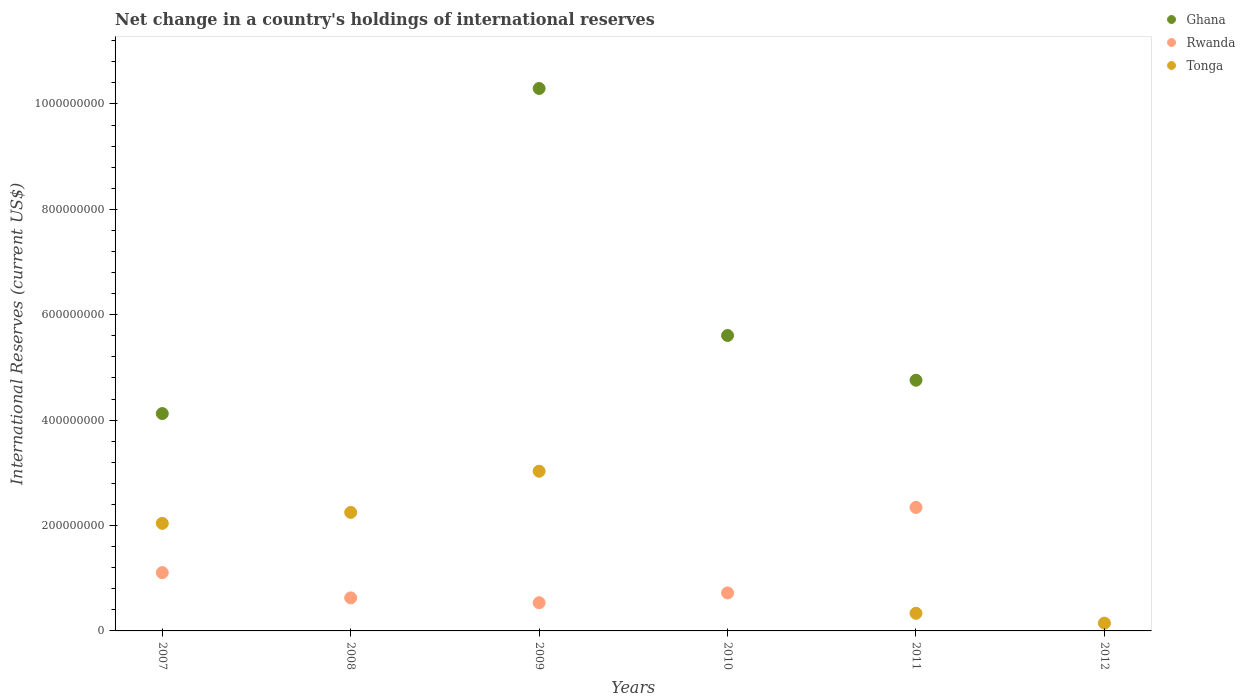How many different coloured dotlines are there?
Make the answer very short. 3. Is the number of dotlines equal to the number of legend labels?
Provide a succinct answer. No. What is the international reserves in Ghana in 2008?
Ensure brevity in your answer.  0. Across all years, what is the maximum international reserves in Ghana?
Give a very brief answer. 1.03e+09. Across all years, what is the minimum international reserves in Rwanda?
Provide a short and direct response. 0. What is the total international reserves in Rwanda in the graph?
Provide a succinct answer. 5.33e+08. What is the difference between the international reserves in Rwanda in 2007 and that in 2011?
Ensure brevity in your answer.  -1.24e+08. What is the difference between the international reserves in Ghana in 2011 and the international reserves in Tonga in 2008?
Provide a succinct answer. 2.51e+08. What is the average international reserves in Ghana per year?
Your answer should be compact. 4.13e+08. In the year 2009, what is the difference between the international reserves in Rwanda and international reserves in Tonga?
Your answer should be compact. -2.49e+08. What is the ratio of the international reserves in Tonga in 2007 to that in 2008?
Your answer should be very brief. 0.91. Is the international reserves in Ghana in 2007 less than that in 2011?
Make the answer very short. Yes. Is the difference between the international reserves in Rwanda in 2007 and 2009 greater than the difference between the international reserves in Tonga in 2007 and 2009?
Your response must be concise. Yes. What is the difference between the highest and the second highest international reserves in Tonga?
Provide a succinct answer. 7.81e+07. What is the difference between the highest and the lowest international reserves in Tonga?
Your response must be concise. 3.03e+08. In how many years, is the international reserves in Rwanda greater than the average international reserves in Rwanda taken over all years?
Give a very brief answer. 2. Is it the case that in every year, the sum of the international reserves in Tonga and international reserves in Rwanda  is greater than the international reserves in Ghana?
Your answer should be compact. No. Does the international reserves in Tonga monotonically increase over the years?
Provide a short and direct response. No. Is the international reserves in Ghana strictly greater than the international reserves in Tonga over the years?
Your answer should be compact. No. Is the international reserves in Ghana strictly less than the international reserves in Rwanda over the years?
Offer a very short reply. No. How many years are there in the graph?
Give a very brief answer. 6. Are the values on the major ticks of Y-axis written in scientific E-notation?
Make the answer very short. No. Does the graph contain any zero values?
Make the answer very short. Yes. How many legend labels are there?
Make the answer very short. 3. What is the title of the graph?
Your response must be concise. Net change in a country's holdings of international reserves. What is the label or title of the Y-axis?
Your answer should be very brief. International Reserves (current US$). What is the International Reserves (current US$) of Ghana in 2007?
Your answer should be very brief. 4.12e+08. What is the International Reserves (current US$) in Rwanda in 2007?
Give a very brief answer. 1.11e+08. What is the International Reserves (current US$) of Tonga in 2007?
Give a very brief answer. 2.04e+08. What is the International Reserves (current US$) in Ghana in 2008?
Provide a short and direct response. 0. What is the International Reserves (current US$) of Rwanda in 2008?
Offer a very short reply. 6.27e+07. What is the International Reserves (current US$) of Tonga in 2008?
Provide a succinct answer. 2.25e+08. What is the International Reserves (current US$) of Ghana in 2009?
Your answer should be very brief. 1.03e+09. What is the International Reserves (current US$) of Rwanda in 2009?
Keep it short and to the point. 5.35e+07. What is the International Reserves (current US$) in Tonga in 2009?
Give a very brief answer. 3.03e+08. What is the International Reserves (current US$) in Ghana in 2010?
Your response must be concise. 5.61e+08. What is the International Reserves (current US$) of Rwanda in 2010?
Your answer should be very brief. 7.21e+07. What is the International Reserves (current US$) of Ghana in 2011?
Keep it short and to the point. 4.76e+08. What is the International Reserves (current US$) of Rwanda in 2011?
Provide a short and direct response. 2.34e+08. What is the International Reserves (current US$) of Tonga in 2011?
Ensure brevity in your answer.  3.35e+07. What is the International Reserves (current US$) of Ghana in 2012?
Offer a terse response. 0. What is the International Reserves (current US$) of Rwanda in 2012?
Ensure brevity in your answer.  0. What is the International Reserves (current US$) in Tonga in 2012?
Make the answer very short. 1.48e+07. Across all years, what is the maximum International Reserves (current US$) in Ghana?
Provide a short and direct response. 1.03e+09. Across all years, what is the maximum International Reserves (current US$) of Rwanda?
Offer a very short reply. 2.34e+08. Across all years, what is the maximum International Reserves (current US$) of Tonga?
Your answer should be very brief. 3.03e+08. What is the total International Reserves (current US$) of Ghana in the graph?
Ensure brevity in your answer.  2.48e+09. What is the total International Reserves (current US$) of Rwanda in the graph?
Ensure brevity in your answer.  5.33e+08. What is the total International Reserves (current US$) in Tonga in the graph?
Provide a short and direct response. 7.80e+08. What is the difference between the International Reserves (current US$) of Rwanda in 2007 and that in 2008?
Offer a terse response. 4.79e+07. What is the difference between the International Reserves (current US$) of Tonga in 2007 and that in 2008?
Make the answer very short. -2.07e+07. What is the difference between the International Reserves (current US$) in Ghana in 2007 and that in 2009?
Your answer should be compact. -6.17e+08. What is the difference between the International Reserves (current US$) of Rwanda in 2007 and that in 2009?
Provide a succinct answer. 5.71e+07. What is the difference between the International Reserves (current US$) in Tonga in 2007 and that in 2009?
Provide a succinct answer. -9.89e+07. What is the difference between the International Reserves (current US$) of Ghana in 2007 and that in 2010?
Keep it short and to the point. -1.48e+08. What is the difference between the International Reserves (current US$) of Rwanda in 2007 and that in 2010?
Provide a succinct answer. 3.85e+07. What is the difference between the International Reserves (current US$) in Ghana in 2007 and that in 2011?
Make the answer very short. -6.33e+07. What is the difference between the International Reserves (current US$) in Rwanda in 2007 and that in 2011?
Ensure brevity in your answer.  -1.24e+08. What is the difference between the International Reserves (current US$) of Tonga in 2007 and that in 2011?
Your answer should be compact. 1.71e+08. What is the difference between the International Reserves (current US$) in Tonga in 2007 and that in 2012?
Ensure brevity in your answer.  1.89e+08. What is the difference between the International Reserves (current US$) in Rwanda in 2008 and that in 2009?
Give a very brief answer. 9.17e+06. What is the difference between the International Reserves (current US$) in Tonga in 2008 and that in 2009?
Your answer should be compact. -7.81e+07. What is the difference between the International Reserves (current US$) in Rwanda in 2008 and that in 2010?
Offer a very short reply. -9.38e+06. What is the difference between the International Reserves (current US$) of Rwanda in 2008 and that in 2011?
Provide a succinct answer. -1.72e+08. What is the difference between the International Reserves (current US$) in Tonga in 2008 and that in 2011?
Provide a succinct answer. 1.91e+08. What is the difference between the International Reserves (current US$) of Tonga in 2008 and that in 2012?
Make the answer very short. 2.10e+08. What is the difference between the International Reserves (current US$) in Ghana in 2009 and that in 2010?
Keep it short and to the point. 4.69e+08. What is the difference between the International Reserves (current US$) of Rwanda in 2009 and that in 2010?
Your answer should be very brief. -1.85e+07. What is the difference between the International Reserves (current US$) in Ghana in 2009 and that in 2011?
Your answer should be compact. 5.54e+08. What is the difference between the International Reserves (current US$) of Rwanda in 2009 and that in 2011?
Provide a short and direct response. -1.81e+08. What is the difference between the International Reserves (current US$) in Tonga in 2009 and that in 2011?
Offer a terse response. 2.70e+08. What is the difference between the International Reserves (current US$) in Tonga in 2009 and that in 2012?
Give a very brief answer. 2.88e+08. What is the difference between the International Reserves (current US$) in Ghana in 2010 and that in 2011?
Make the answer very short. 8.49e+07. What is the difference between the International Reserves (current US$) of Rwanda in 2010 and that in 2011?
Offer a very short reply. -1.62e+08. What is the difference between the International Reserves (current US$) of Tonga in 2011 and that in 2012?
Provide a succinct answer. 1.87e+07. What is the difference between the International Reserves (current US$) of Ghana in 2007 and the International Reserves (current US$) of Rwanda in 2008?
Your response must be concise. 3.50e+08. What is the difference between the International Reserves (current US$) of Ghana in 2007 and the International Reserves (current US$) of Tonga in 2008?
Provide a succinct answer. 1.88e+08. What is the difference between the International Reserves (current US$) in Rwanda in 2007 and the International Reserves (current US$) in Tonga in 2008?
Give a very brief answer. -1.14e+08. What is the difference between the International Reserves (current US$) of Ghana in 2007 and the International Reserves (current US$) of Rwanda in 2009?
Keep it short and to the point. 3.59e+08. What is the difference between the International Reserves (current US$) of Ghana in 2007 and the International Reserves (current US$) of Tonga in 2009?
Give a very brief answer. 1.09e+08. What is the difference between the International Reserves (current US$) in Rwanda in 2007 and the International Reserves (current US$) in Tonga in 2009?
Offer a very short reply. -1.92e+08. What is the difference between the International Reserves (current US$) in Ghana in 2007 and the International Reserves (current US$) in Rwanda in 2010?
Keep it short and to the point. 3.40e+08. What is the difference between the International Reserves (current US$) of Ghana in 2007 and the International Reserves (current US$) of Rwanda in 2011?
Give a very brief answer. 1.78e+08. What is the difference between the International Reserves (current US$) of Ghana in 2007 and the International Reserves (current US$) of Tonga in 2011?
Give a very brief answer. 3.79e+08. What is the difference between the International Reserves (current US$) in Rwanda in 2007 and the International Reserves (current US$) in Tonga in 2011?
Give a very brief answer. 7.71e+07. What is the difference between the International Reserves (current US$) in Ghana in 2007 and the International Reserves (current US$) in Tonga in 2012?
Offer a terse response. 3.98e+08. What is the difference between the International Reserves (current US$) of Rwanda in 2007 and the International Reserves (current US$) of Tonga in 2012?
Your answer should be compact. 9.58e+07. What is the difference between the International Reserves (current US$) in Rwanda in 2008 and the International Reserves (current US$) in Tonga in 2009?
Ensure brevity in your answer.  -2.40e+08. What is the difference between the International Reserves (current US$) in Rwanda in 2008 and the International Reserves (current US$) in Tonga in 2011?
Ensure brevity in your answer.  2.92e+07. What is the difference between the International Reserves (current US$) in Rwanda in 2008 and the International Reserves (current US$) in Tonga in 2012?
Ensure brevity in your answer.  4.79e+07. What is the difference between the International Reserves (current US$) in Ghana in 2009 and the International Reserves (current US$) in Rwanda in 2010?
Provide a short and direct response. 9.57e+08. What is the difference between the International Reserves (current US$) in Ghana in 2009 and the International Reserves (current US$) in Rwanda in 2011?
Provide a succinct answer. 7.95e+08. What is the difference between the International Reserves (current US$) of Ghana in 2009 and the International Reserves (current US$) of Tonga in 2011?
Offer a terse response. 9.96e+08. What is the difference between the International Reserves (current US$) in Rwanda in 2009 and the International Reserves (current US$) in Tonga in 2011?
Give a very brief answer. 2.00e+07. What is the difference between the International Reserves (current US$) in Ghana in 2009 and the International Reserves (current US$) in Tonga in 2012?
Your answer should be very brief. 1.01e+09. What is the difference between the International Reserves (current US$) in Rwanda in 2009 and the International Reserves (current US$) in Tonga in 2012?
Your response must be concise. 3.87e+07. What is the difference between the International Reserves (current US$) of Ghana in 2010 and the International Reserves (current US$) of Rwanda in 2011?
Make the answer very short. 3.26e+08. What is the difference between the International Reserves (current US$) in Ghana in 2010 and the International Reserves (current US$) in Tonga in 2011?
Provide a succinct answer. 5.27e+08. What is the difference between the International Reserves (current US$) in Rwanda in 2010 and the International Reserves (current US$) in Tonga in 2011?
Your answer should be very brief. 3.86e+07. What is the difference between the International Reserves (current US$) in Ghana in 2010 and the International Reserves (current US$) in Tonga in 2012?
Make the answer very short. 5.46e+08. What is the difference between the International Reserves (current US$) in Rwanda in 2010 and the International Reserves (current US$) in Tonga in 2012?
Your response must be concise. 5.73e+07. What is the difference between the International Reserves (current US$) in Ghana in 2011 and the International Reserves (current US$) in Tonga in 2012?
Provide a succinct answer. 4.61e+08. What is the difference between the International Reserves (current US$) in Rwanda in 2011 and the International Reserves (current US$) in Tonga in 2012?
Your answer should be compact. 2.20e+08. What is the average International Reserves (current US$) of Ghana per year?
Your answer should be compact. 4.13e+08. What is the average International Reserves (current US$) of Rwanda per year?
Keep it short and to the point. 8.89e+07. What is the average International Reserves (current US$) of Tonga per year?
Your response must be concise. 1.30e+08. In the year 2007, what is the difference between the International Reserves (current US$) in Ghana and International Reserves (current US$) in Rwanda?
Make the answer very short. 3.02e+08. In the year 2007, what is the difference between the International Reserves (current US$) in Ghana and International Reserves (current US$) in Tonga?
Provide a short and direct response. 2.08e+08. In the year 2007, what is the difference between the International Reserves (current US$) in Rwanda and International Reserves (current US$) in Tonga?
Make the answer very short. -9.35e+07. In the year 2008, what is the difference between the International Reserves (current US$) in Rwanda and International Reserves (current US$) in Tonga?
Your answer should be very brief. -1.62e+08. In the year 2009, what is the difference between the International Reserves (current US$) of Ghana and International Reserves (current US$) of Rwanda?
Keep it short and to the point. 9.76e+08. In the year 2009, what is the difference between the International Reserves (current US$) in Ghana and International Reserves (current US$) in Tonga?
Give a very brief answer. 7.26e+08. In the year 2009, what is the difference between the International Reserves (current US$) in Rwanda and International Reserves (current US$) in Tonga?
Provide a short and direct response. -2.49e+08. In the year 2010, what is the difference between the International Reserves (current US$) in Ghana and International Reserves (current US$) in Rwanda?
Your answer should be very brief. 4.89e+08. In the year 2011, what is the difference between the International Reserves (current US$) in Ghana and International Reserves (current US$) in Rwanda?
Make the answer very short. 2.41e+08. In the year 2011, what is the difference between the International Reserves (current US$) of Ghana and International Reserves (current US$) of Tonga?
Make the answer very short. 4.42e+08. In the year 2011, what is the difference between the International Reserves (current US$) of Rwanda and International Reserves (current US$) of Tonga?
Provide a short and direct response. 2.01e+08. What is the ratio of the International Reserves (current US$) of Rwanda in 2007 to that in 2008?
Give a very brief answer. 1.76. What is the ratio of the International Reserves (current US$) in Tonga in 2007 to that in 2008?
Your answer should be very brief. 0.91. What is the ratio of the International Reserves (current US$) of Ghana in 2007 to that in 2009?
Keep it short and to the point. 0.4. What is the ratio of the International Reserves (current US$) in Rwanda in 2007 to that in 2009?
Provide a succinct answer. 2.07. What is the ratio of the International Reserves (current US$) in Tonga in 2007 to that in 2009?
Ensure brevity in your answer.  0.67. What is the ratio of the International Reserves (current US$) of Ghana in 2007 to that in 2010?
Keep it short and to the point. 0.74. What is the ratio of the International Reserves (current US$) in Rwanda in 2007 to that in 2010?
Provide a short and direct response. 1.53. What is the ratio of the International Reserves (current US$) of Ghana in 2007 to that in 2011?
Your answer should be compact. 0.87. What is the ratio of the International Reserves (current US$) in Rwanda in 2007 to that in 2011?
Ensure brevity in your answer.  0.47. What is the ratio of the International Reserves (current US$) of Tonga in 2007 to that in 2011?
Ensure brevity in your answer.  6.09. What is the ratio of the International Reserves (current US$) in Tonga in 2007 to that in 2012?
Offer a very short reply. 13.78. What is the ratio of the International Reserves (current US$) in Rwanda in 2008 to that in 2009?
Your answer should be compact. 1.17. What is the ratio of the International Reserves (current US$) of Tonga in 2008 to that in 2009?
Offer a terse response. 0.74. What is the ratio of the International Reserves (current US$) of Rwanda in 2008 to that in 2010?
Offer a very short reply. 0.87. What is the ratio of the International Reserves (current US$) of Rwanda in 2008 to that in 2011?
Provide a succinct answer. 0.27. What is the ratio of the International Reserves (current US$) in Tonga in 2008 to that in 2011?
Give a very brief answer. 6.71. What is the ratio of the International Reserves (current US$) in Tonga in 2008 to that in 2012?
Your answer should be very brief. 15.18. What is the ratio of the International Reserves (current US$) of Ghana in 2009 to that in 2010?
Your answer should be compact. 1.84. What is the ratio of the International Reserves (current US$) of Rwanda in 2009 to that in 2010?
Your response must be concise. 0.74. What is the ratio of the International Reserves (current US$) of Ghana in 2009 to that in 2011?
Make the answer very short. 2.16. What is the ratio of the International Reserves (current US$) of Rwanda in 2009 to that in 2011?
Provide a succinct answer. 0.23. What is the ratio of the International Reserves (current US$) in Tonga in 2009 to that in 2011?
Offer a terse response. 9.04. What is the ratio of the International Reserves (current US$) in Tonga in 2009 to that in 2012?
Give a very brief answer. 20.46. What is the ratio of the International Reserves (current US$) in Ghana in 2010 to that in 2011?
Offer a terse response. 1.18. What is the ratio of the International Reserves (current US$) in Rwanda in 2010 to that in 2011?
Give a very brief answer. 0.31. What is the ratio of the International Reserves (current US$) of Tonga in 2011 to that in 2012?
Ensure brevity in your answer.  2.26. What is the difference between the highest and the second highest International Reserves (current US$) in Ghana?
Keep it short and to the point. 4.69e+08. What is the difference between the highest and the second highest International Reserves (current US$) of Rwanda?
Your response must be concise. 1.24e+08. What is the difference between the highest and the second highest International Reserves (current US$) of Tonga?
Make the answer very short. 7.81e+07. What is the difference between the highest and the lowest International Reserves (current US$) in Ghana?
Your response must be concise. 1.03e+09. What is the difference between the highest and the lowest International Reserves (current US$) in Rwanda?
Keep it short and to the point. 2.34e+08. What is the difference between the highest and the lowest International Reserves (current US$) of Tonga?
Keep it short and to the point. 3.03e+08. 